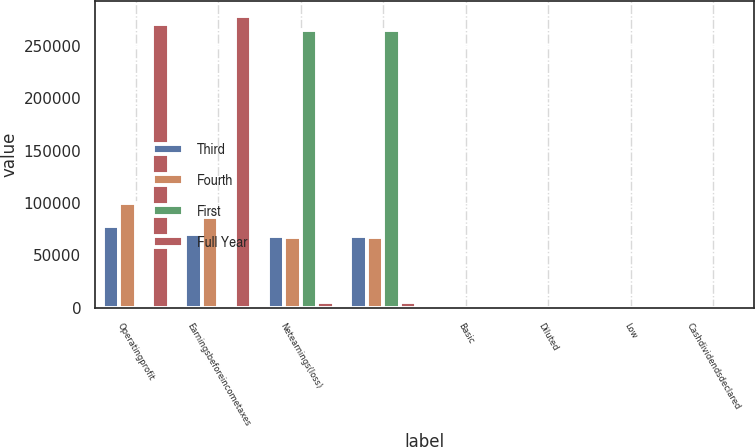<chart> <loc_0><loc_0><loc_500><loc_500><stacked_bar_chart><ecel><fcel>Operatingprofit<fcel>Earningsbeforeincometaxes<fcel>Netearnings(loss)<fcel>Unnamed: 4<fcel>Basic<fcel>Diluted<fcel>Low<fcel>Cashdividendsdeclared<nl><fcel>Third<fcel>78343<fcel>70837<fcel>68599<fcel>68599<fcel>0.55<fcel>0.54<fcel>77.2<fcel>0.57<nl><fcel>Fourth<fcel>99984<fcel>86886<fcel>67723<fcel>67723<fcel>0.54<fcel>0.53<fcel>94.76<fcel>0.57<nl><fcel>First<fcel>93.165<fcel>93.165<fcel>265583<fcel>265583<fcel>2.12<fcel>2.09<fcel>91.57<fcel>0.57<nl><fcel>Full Year<fcel>271088<fcel>278586<fcel>5298<fcel>5298<fcel>0.04<fcel>0.04<fcel>87.92<fcel>0.57<nl></chart> 